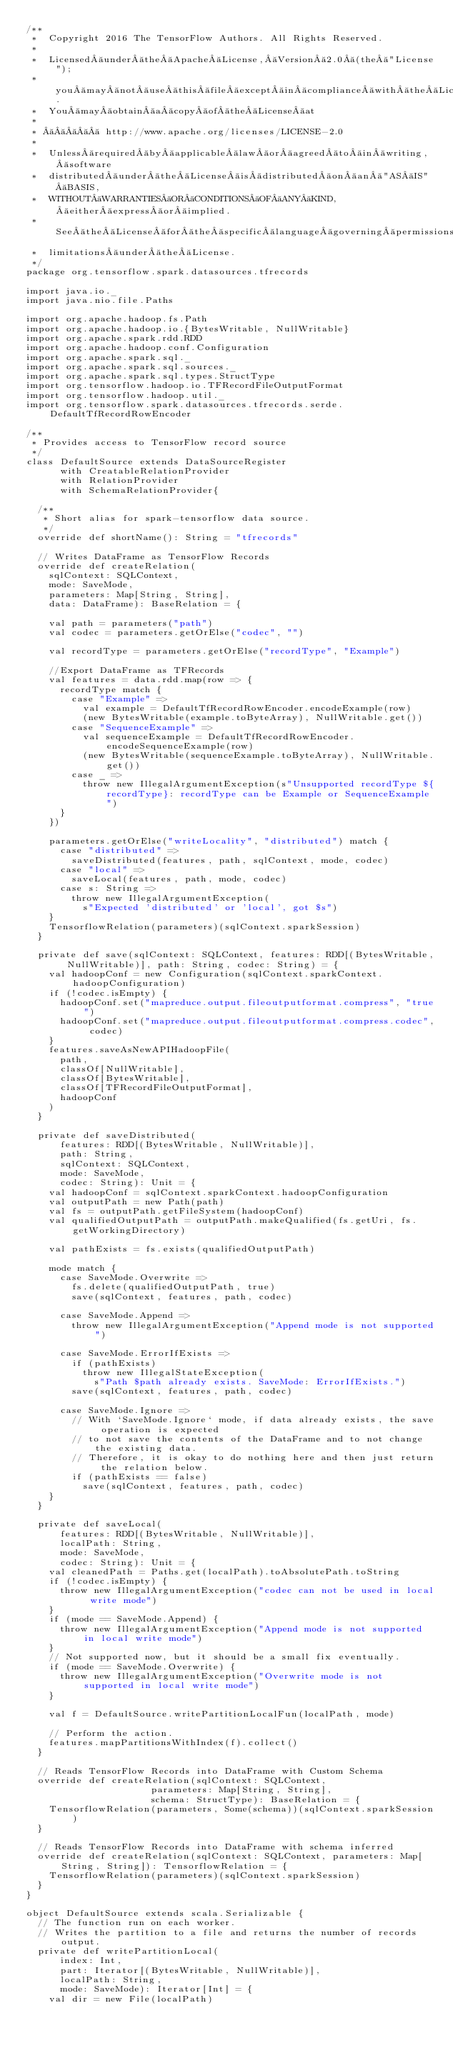Convert code to text. <code><loc_0><loc_0><loc_500><loc_500><_Scala_>/**
 *  Copyright 2016 The TensorFlow Authors. All Rights Reserved.
 *
 *  Licensed under the Apache License, Version 2.0 (the "License");
 *  you may not use this file except in compliance with the License.
 *  You may obtain a copy of the License at
 *
 *       http://www.apache.org/licenses/LICENSE-2.0
 *
 *  Unless required by applicable law or agreed to in writing, software
 *  distributed under the License is distributed on an "AS IS" BASIS,
 *  WITHOUT WARRANTIES OR CONDITIONS OF ANY KIND, either express or implied.
 *  See the License for the specific language governing permissions and
 *  limitations under the License.
 */
package org.tensorflow.spark.datasources.tfrecords

import java.io._
import java.nio.file.Paths

import org.apache.hadoop.fs.Path
import org.apache.hadoop.io.{BytesWritable, NullWritable}
import org.apache.spark.rdd.RDD
import org.apache.hadoop.conf.Configuration
import org.apache.spark.sql._
import org.apache.spark.sql.sources._
import org.apache.spark.sql.types.StructType
import org.tensorflow.hadoop.io.TFRecordFileOutputFormat
import org.tensorflow.hadoop.util._
import org.tensorflow.spark.datasources.tfrecords.serde.DefaultTfRecordRowEncoder

/**
 * Provides access to TensorFlow record source
 */
class DefaultSource extends DataSourceRegister
      with CreatableRelationProvider
      with RelationProvider
      with SchemaRelationProvider{

  /**
   * Short alias for spark-tensorflow data source.
   */
  override def shortName(): String = "tfrecords"

  // Writes DataFrame as TensorFlow Records
  override def createRelation(
    sqlContext: SQLContext,
    mode: SaveMode,
    parameters: Map[String, String],
    data: DataFrame): BaseRelation = {

    val path = parameters("path")
    val codec = parameters.getOrElse("codec", "")

    val recordType = parameters.getOrElse("recordType", "Example")

    //Export DataFrame as TFRecords
    val features = data.rdd.map(row => {
      recordType match {
        case "Example" =>
          val example = DefaultTfRecordRowEncoder.encodeExample(row)
          (new BytesWritable(example.toByteArray), NullWritable.get())
        case "SequenceExample" =>
          val sequenceExample = DefaultTfRecordRowEncoder.encodeSequenceExample(row)
          (new BytesWritable(sequenceExample.toByteArray), NullWritable.get())
        case _ =>
          throw new IllegalArgumentException(s"Unsupported recordType ${recordType}: recordType can be Example or SequenceExample")
      }
    })

    parameters.getOrElse("writeLocality", "distributed") match {
      case "distributed" =>
        saveDistributed(features, path, sqlContext, mode, codec)
      case "local" =>
        saveLocal(features, path, mode, codec)
      case s: String =>
        throw new IllegalArgumentException(
          s"Expected 'distributed' or 'local', got $s")
    }
    TensorflowRelation(parameters)(sqlContext.sparkSession)
  }

  private def save(sqlContext: SQLContext, features: RDD[(BytesWritable, NullWritable)], path: String, codec: String) = {
    val hadoopConf = new Configuration(sqlContext.sparkContext.hadoopConfiguration)
    if (!codec.isEmpty) {
      hadoopConf.set("mapreduce.output.fileoutputformat.compress", "true")
      hadoopConf.set("mapreduce.output.fileoutputformat.compress.codec", codec)
    }
    features.saveAsNewAPIHadoopFile(
      path,
      classOf[NullWritable],
      classOf[BytesWritable],
      classOf[TFRecordFileOutputFormat],
      hadoopConf
    )
  }

  private def saveDistributed(
      features: RDD[(BytesWritable, NullWritable)],
      path: String,
      sqlContext: SQLContext,
      mode: SaveMode,
      codec: String): Unit = {
    val hadoopConf = sqlContext.sparkContext.hadoopConfiguration
    val outputPath = new Path(path)
    val fs = outputPath.getFileSystem(hadoopConf)
    val qualifiedOutputPath = outputPath.makeQualified(fs.getUri, fs.getWorkingDirectory)

    val pathExists = fs.exists(qualifiedOutputPath)

    mode match {
      case SaveMode.Overwrite =>
        fs.delete(qualifiedOutputPath, true)
        save(sqlContext, features, path, codec)

      case SaveMode.Append =>
        throw new IllegalArgumentException("Append mode is not supported")

      case SaveMode.ErrorIfExists =>
        if (pathExists)
          throw new IllegalStateException(
            s"Path $path already exists. SaveMode: ErrorIfExists.")
        save(sqlContext, features, path, codec)

      case SaveMode.Ignore =>
        // With `SaveMode.Ignore` mode, if data already exists, the save operation is expected
        // to not save the contents of the DataFrame and to not change the existing data.
        // Therefore, it is okay to do nothing here and then just return the relation below.
        if (pathExists == false)
          save(sqlContext, features, path, codec)
    }
  }

  private def saveLocal(
      features: RDD[(BytesWritable, NullWritable)],
      localPath: String,
      mode: SaveMode,
      codec: String): Unit = {
    val cleanedPath = Paths.get(localPath).toAbsolutePath.toString
    if (!codec.isEmpty) {
      throw new IllegalArgumentException("codec can not be used in local write mode")
    }
    if (mode == SaveMode.Append) {
      throw new IllegalArgumentException("Append mode is not supported in local write mode")
    }
    // Not supported now, but it should be a small fix eventually.
    if (mode == SaveMode.Overwrite) {
      throw new IllegalArgumentException("Overwrite mode is not supported in local write mode")
    }

    val f = DefaultSource.writePartitionLocalFun(localPath, mode)

    // Perform the action.
    features.mapPartitionsWithIndex(f).collect()
  }

  // Reads TensorFlow Records into DataFrame with Custom Schema
  override def createRelation(sqlContext: SQLContext,
                      parameters: Map[String, String],
                      schema: StructType): BaseRelation = {
    TensorflowRelation(parameters, Some(schema))(sqlContext.sparkSession)
  }

  // Reads TensorFlow Records into DataFrame with schema inferred
  override def createRelation(sqlContext: SQLContext, parameters: Map[String, String]): TensorflowRelation = {
    TensorflowRelation(parameters)(sqlContext.sparkSession)
  }
}

object DefaultSource extends scala.Serializable {
  // The function run on each worker.
  // Writes the partition to a file and returns the number of records output.
  private def writePartitionLocal(
      index: Int,
      part: Iterator[(BytesWritable, NullWritable)],
      localPath: String,
      mode: SaveMode): Iterator[Int] = {
    val dir = new File(localPath)</code> 